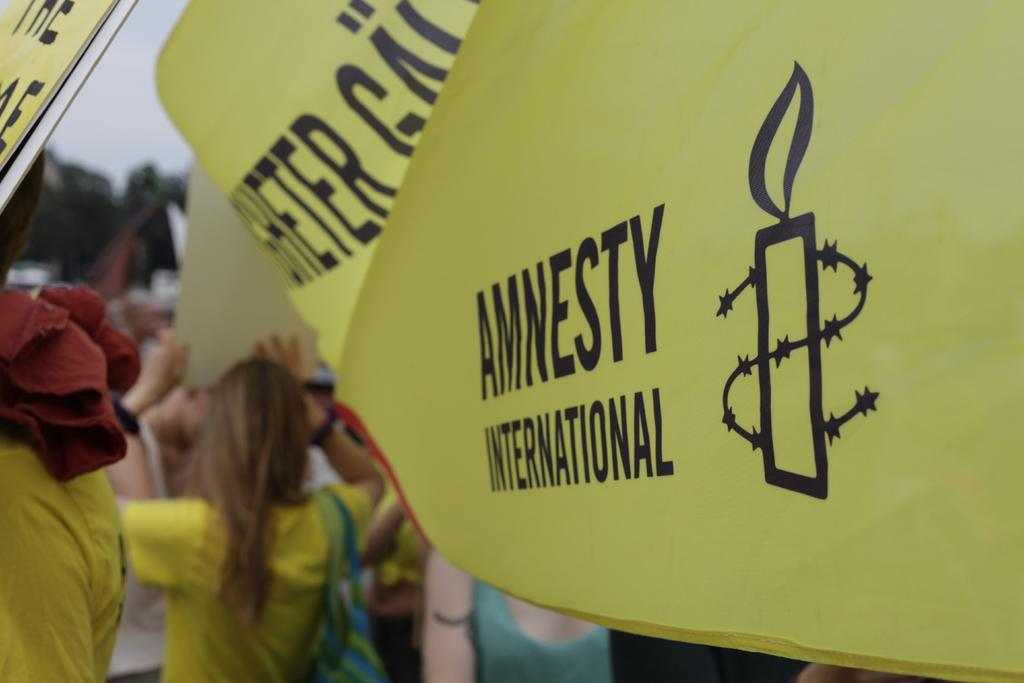What objects can be seen in the image? There are placards in the image. Are there any living beings in the image? Yes, there are people in the image. What can be seen in the background of the image? There is greenery and the sky visible in the background of the image. What type of toys can be seen in the image? There are no toys present in the image. Can you describe the root system of the plants in the image? There are no plants or roots visible in the image; only placards, people, greenery, and the sky can be seen. 